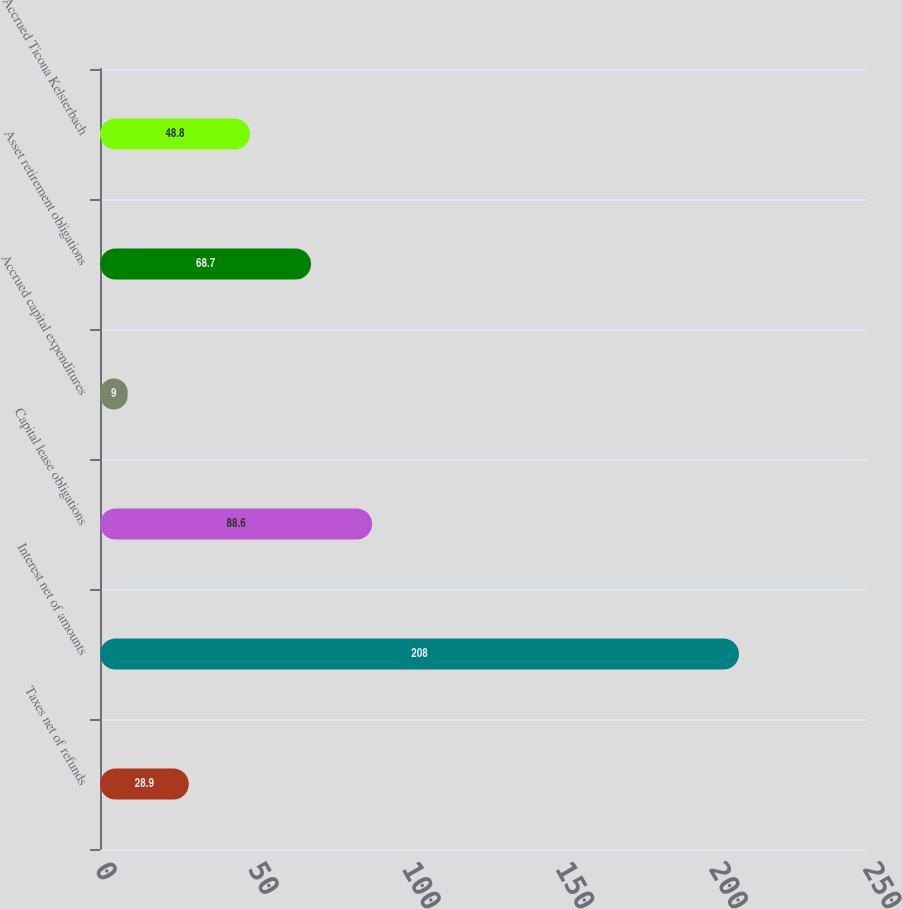Convert chart. <chart><loc_0><loc_0><loc_500><loc_500><bar_chart><fcel>Taxes net of refunds<fcel>Interest net of amounts<fcel>Capital lease obligations<fcel>Accrued capital expenditures<fcel>Asset retirement obligations<fcel>Accrued Ticona Kelsterbach<nl><fcel>28.9<fcel>208<fcel>88.6<fcel>9<fcel>68.7<fcel>48.8<nl></chart> 